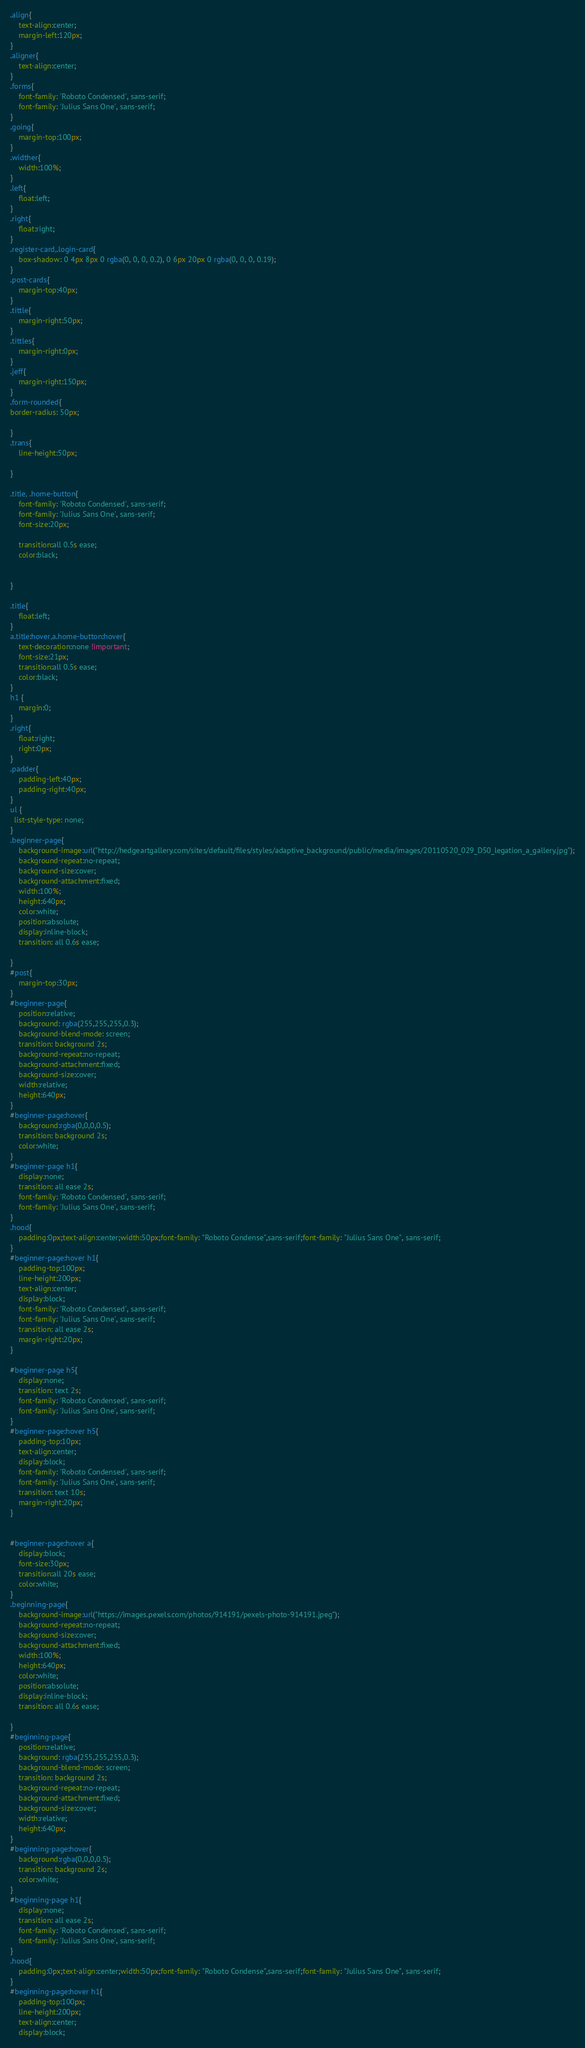<code> <loc_0><loc_0><loc_500><loc_500><_CSS_>.align{
	text-align:center;
	margin-left:120px;
}
.aligner{
	text-align:center;
}
.forms{
	font-family: 'Roboto Condensed', sans-serif;
	font-family: 'Julius Sans One', sans-serif;
}
.going{
	margin-top:100px;
}
.widther{
	width:100%;
}
.left{
	float:left;
}
.right{
	float:right;
}
.register-card,.login-card{
	box-shadow: 0 4px 8px 0 rgba(0, 0, 0, 0.2), 0 6px 20px 0 rgba(0, 0, 0, 0.19);
}
.post-cards{
	margin-top:40px;
}
.tittle{
	margin-right:50px;
}
.tittles{
	margin-right:0px;
}
.jeff{
	margin-right:150px;
}
.form-rounded{
border-radius: 50px;

}
.trans{
	line-height:50px;

}

.title, .home-button{
	font-family: 'Roboto Condensed', sans-serif;
	font-family: 'Julius Sans One', sans-serif;
	font-size:20px;
	
	transition:all 0.5s ease;
	color:black;
	

}

.title{
	float:left;
}
a.title:hover,a.home-button:hover{
	text-decoration:none !important;
	font-size:21px;
	transition:all 0.5s ease;
	color:black;
}
h1 {
	margin:0;
}
.right{
	float:right;
	right:0px;
}
.padder{
	padding-left:40px;
	padding-right:40px;
}
ul {
  list-style-type: none;
}
.beginner-page{
	background-image:url("http://hedgeartgallery.com/sites/default/files/styles/adaptive_background/public/media/images/20110520_029_D50_legation_a_gallery.jpg");
	background-repeat:no-repeat;
	background-size:cover;
	background-attachment:fixed;
	width:100%;
	height:640px;
	color:white;
	position:absolute;
	display:inline-block;
	transition: all 0.6s ease;

}
#post{
	margin-top:30px;
}
#beginner-page{
	position:relative;
	background: rgba(255,255,255,0.3);
	background-blend-mode: screen;
	transition: background 2s;
	background-repeat:no-repeat;
	background-attachment:fixed;
	background-size:cover;
	width:relative;
	height:640px;
}
#beginner-page:hover{
	background:rgba(0,0,0,0.5);
	transition: background 2s;
	color:white;
}
#beginner-page h1{
	display:none;
	transition: all ease 2s;
	font-family: 'Roboto Condensed', sans-serif;
	font-family: 'Julius Sans One', sans-serif;
}
.hood{
	padding:0px;text-align:center;width:50px;font-family: "Roboto Condense",sans-serif;font-family: "Julius Sans One", sans-serif;
}
#beginner-page:hover h1{
	padding-top:100px;
	line-height:200px;
	text-align:center;
	display:block;
	font-family: 'Roboto Condensed', sans-serif;
	font-family: 'Julius Sans One', sans-serif;
	transition: all ease 2s;
	margin-right:20px;
}

#beginner-page h5{
	display:none;
	transition: text 2s;
	font-family: 'Roboto Condensed', sans-serif;
	font-family: 'Julius Sans One', sans-serif;
}
#beginner-page:hover h5{
	padding-top:10px;
	text-align:center;
	display:block;
	font-family: 'Roboto Condensed', sans-serif;
	font-family: 'Julius Sans One', sans-serif;
	transition: text 10s;
	margin-right:20px;
}


#beginner-page:hover a{
	display:block;
	font-size:30px;
	transition:all 20s ease;
	color:white;
}
.beginning-page{
	background-image:url("https://images.pexels.com/photos/914191/pexels-photo-914191.jpeg");
	background-repeat:no-repeat;
	background-size:cover;
	background-attachment:fixed;
	width:100%;
	height:640px;
	color:white;
	position:absolute;
	display:inline-block;
	transition: all 0.6s ease;

}
#beginning-page{
	position:relative;
	background: rgba(255,255,255,0.3);
	background-blend-mode: screen;
	transition: background 2s;
	background-repeat:no-repeat;
	background-attachment:fixed;
	background-size:cover;
	width:relative;
	height:640px;
}
#beginning-page:hover{
	background:rgba(0,0,0,0.5);
	transition: background 2s;
	color:white;
}
#beginning-page h1{
	display:none;
	transition: all ease 2s;
	font-family: 'Roboto Condensed', sans-serif;
	font-family: 'Julius Sans One', sans-serif;
}
.hood{
	padding:0px;text-align:center;width:50px;font-family: "Roboto Condense",sans-serif;font-family: "Julius Sans One", sans-serif;
}
#beginning-page:hover h1{
	padding-top:100px;
	line-height:200px;
	text-align:center;
	display:block;</code> 